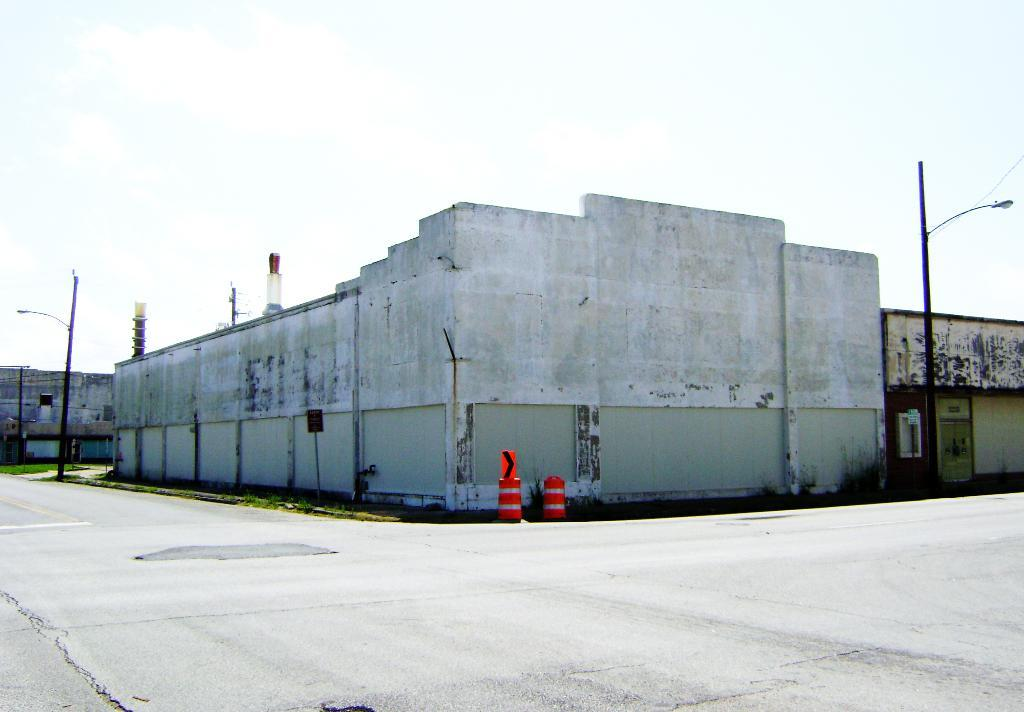What type of surface can be seen in the image? There is a road in the image. What type of vegetation is present in the image? There is grass in the image. What type of structures can be seen in the image? There are poles and buildings in the image. What other objects can be seen in the image? There are some objects in the image. What is visible in the background of the image? The sky is visible in the background of the image. How does the juice flow through the image? There is no juice present in the image, so it cannot flow through the image. What type of wash is depicted in the image? There is no wash or washing activity depicted in the image. 